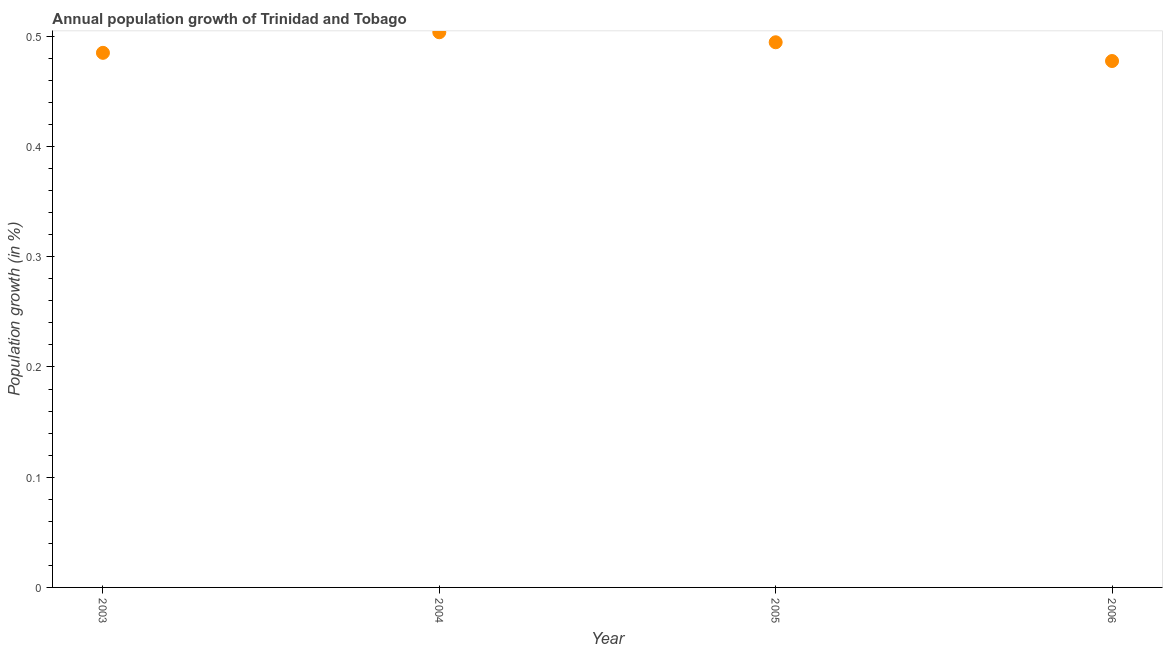What is the population growth in 2003?
Your answer should be very brief. 0.48. Across all years, what is the maximum population growth?
Ensure brevity in your answer.  0.5. Across all years, what is the minimum population growth?
Your response must be concise. 0.48. What is the sum of the population growth?
Provide a short and direct response. 1.96. What is the difference between the population growth in 2005 and 2006?
Provide a short and direct response. 0.02. What is the average population growth per year?
Ensure brevity in your answer.  0.49. What is the median population growth?
Your answer should be very brief. 0.49. What is the ratio of the population growth in 2004 to that in 2005?
Make the answer very short. 1.02. What is the difference between the highest and the second highest population growth?
Provide a succinct answer. 0.01. Is the sum of the population growth in 2003 and 2005 greater than the maximum population growth across all years?
Provide a short and direct response. Yes. What is the difference between the highest and the lowest population growth?
Keep it short and to the point. 0.03. How many dotlines are there?
Offer a very short reply. 1. What is the difference between two consecutive major ticks on the Y-axis?
Your answer should be compact. 0.1. Does the graph contain any zero values?
Provide a short and direct response. No. Does the graph contain grids?
Give a very brief answer. No. What is the title of the graph?
Offer a very short reply. Annual population growth of Trinidad and Tobago. What is the label or title of the Y-axis?
Provide a short and direct response. Population growth (in %). What is the Population growth (in %) in 2003?
Your answer should be compact. 0.48. What is the Population growth (in %) in 2004?
Give a very brief answer. 0.5. What is the Population growth (in %) in 2005?
Offer a terse response. 0.49. What is the Population growth (in %) in 2006?
Make the answer very short. 0.48. What is the difference between the Population growth (in %) in 2003 and 2004?
Your answer should be compact. -0.02. What is the difference between the Population growth (in %) in 2003 and 2005?
Make the answer very short. -0.01. What is the difference between the Population growth (in %) in 2003 and 2006?
Keep it short and to the point. 0.01. What is the difference between the Population growth (in %) in 2004 and 2005?
Offer a very short reply. 0.01. What is the difference between the Population growth (in %) in 2004 and 2006?
Provide a short and direct response. 0.03. What is the difference between the Population growth (in %) in 2005 and 2006?
Your response must be concise. 0.02. What is the ratio of the Population growth (in %) in 2004 to that in 2006?
Provide a short and direct response. 1.05. What is the ratio of the Population growth (in %) in 2005 to that in 2006?
Provide a short and direct response. 1.04. 